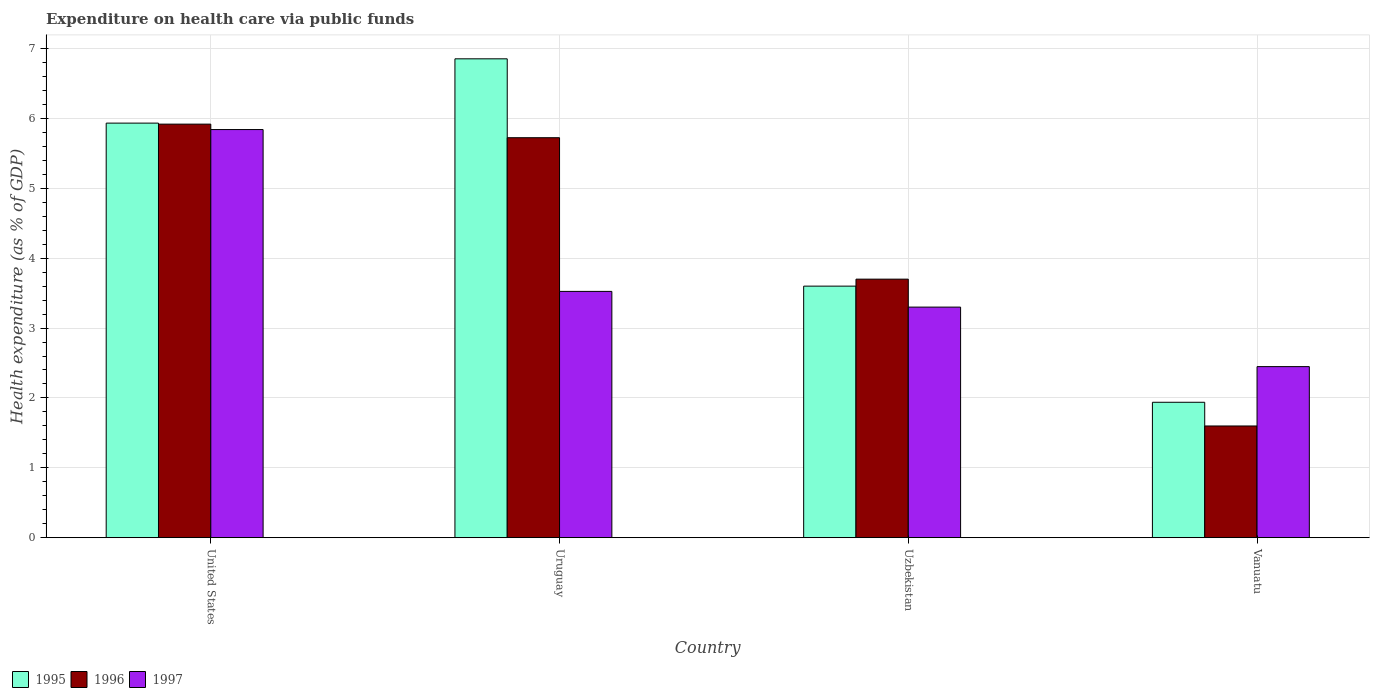How many bars are there on the 3rd tick from the left?
Ensure brevity in your answer.  3. What is the label of the 2nd group of bars from the left?
Keep it short and to the point. Uruguay. What is the expenditure made on health care in 1996 in United States?
Keep it short and to the point. 5.92. Across all countries, what is the maximum expenditure made on health care in 1997?
Ensure brevity in your answer.  5.84. Across all countries, what is the minimum expenditure made on health care in 1996?
Make the answer very short. 1.6. In which country was the expenditure made on health care in 1995 maximum?
Ensure brevity in your answer.  Uruguay. In which country was the expenditure made on health care in 1996 minimum?
Your answer should be very brief. Vanuatu. What is the total expenditure made on health care in 1996 in the graph?
Offer a terse response. 16.94. What is the difference between the expenditure made on health care in 1995 in United States and that in Uruguay?
Offer a terse response. -0.92. What is the difference between the expenditure made on health care in 1996 in Uzbekistan and the expenditure made on health care in 1997 in United States?
Your response must be concise. -2.14. What is the average expenditure made on health care in 1995 per country?
Make the answer very short. 4.58. What is the difference between the expenditure made on health care of/in 1997 and expenditure made on health care of/in 1996 in Uzbekistan?
Keep it short and to the point. -0.4. What is the ratio of the expenditure made on health care in 1995 in United States to that in Vanuatu?
Keep it short and to the point. 3.06. Is the expenditure made on health care in 1996 in United States less than that in Uruguay?
Provide a succinct answer. No. Is the difference between the expenditure made on health care in 1997 in United States and Uzbekistan greater than the difference between the expenditure made on health care in 1996 in United States and Uzbekistan?
Provide a succinct answer. Yes. What is the difference between the highest and the second highest expenditure made on health care in 1997?
Your response must be concise. -0.22. What is the difference between the highest and the lowest expenditure made on health care in 1996?
Make the answer very short. 4.32. In how many countries, is the expenditure made on health care in 1997 greater than the average expenditure made on health care in 1997 taken over all countries?
Offer a very short reply. 1. What does the 3rd bar from the left in Vanuatu represents?
Provide a succinct answer. 1997. Is it the case that in every country, the sum of the expenditure made on health care in 1995 and expenditure made on health care in 1997 is greater than the expenditure made on health care in 1996?
Offer a terse response. Yes. Are all the bars in the graph horizontal?
Give a very brief answer. No. What is the difference between two consecutive major ticks on the Y-axis?
Provide a succinct answer. 1. Are the values on the major ticks of Y-axis written in scientific E-notation?
Give a very brief answer. No. How are the legend labels stacked?
Provide a short and direct response. Horizontal. What is the title of the graph?
Your answer should be compact. Expenditure on health care via public funds. Does "2004" appear as one of the legend labels in the graph?
Keep it short and to the point. No. What is the label or title of the Y-axis?
Offer a terse response. Health expenditure (as % of GDP). What is the Health expenditure (as % of GDP) of 1995 in United States?
Your answer should be very brief. 5.93. What is the Health expenditure (as % of GDP) in 1996 in United States?
Your answer should be very brief. 5.92. What is the Health expenditure (as % of GDP) of 1997 in United States?
Your response must be concise. 5.84. What is the Health expenditure (as % of GDP) of 1995 in Uruguay?
Offer a very short reply. 6.85. What is the Health expenditure (as % of GDP) in 1996 in Uruguay?
Offer a terse response. 5.72. What is the Health expenditure (as % of GDP) in 1997 in Uruguay?
Offer a very short reply. 3.52. What is the Health expenditure (as % of GDP) in 1995 in Uzbekistan?
Provide a succinct answer. 3.6. What is the Health expenditure (as % of GDP) in 1996 in Uzbekistan?
Provide a succinct answer. 3.7. What is the Health expenditure (as % of GDP) in 1997 in Uzbekistan?
Keep it short and to the point. 3.3. What is the Health expenditure (as % of GDP) of 1995 in Vanuatu?
Make the answer very short. 1.94. What is the Health expenditure (as % of GDP) in 1996 in Vanuatu?
Your response must be concise. 1.6. What is the Health expenditure (as % of GDP) in 1997 in Vanuatu?
Your answer should be compact. 2.45. Across all countries, what is the maximum Health expenditure (as % of GDP) in 1995?
Your answer should be compact. 6.85. Across all countries, what is the maximum Health expenditure (as % of GDP) in 1996?
Keep it short and to the point. 5.92. Across all countries, what is the maximum Health expenditure (as % of GDP) of 1997?
Your response must be concise. 5.84. Across all countries, what is the minimum Health expenditure (as % of GDP) in 1995?
Make the answer very short. 1.94. Across all countries, what is the minimum Health expenditure (as % of GDP) in 1996?
Provide a succinct answer. 1.6. Across all countries, what is the minimum Health expenditure (as % of GDP) in 1997?
Your answer should be compact. 2.45. What is the total Health expenditure (as % of GDP) in 1995 in the graph?
Offer a terse response. 18.32. What is the total Health expenditure (as % of GDP) in 1996 in the graph?
Your answer should be very brief. 16.94. What is the total Health expenditure (as % of GDP) of 1997 in the graph?
Your response must be concise. 15.11. What is the difference between the Health expenditure (as % of GDP) of 1995 in United States and that in Uruguay?
Offer a terse response. -0.92. What is the difference between the Health expenditure (as % of GDP) in 1996 in United States and that in Uruguay?
Your answer should be very brief. 0.19. What is the difference between the Health expenditure (as % of GDP) of 1997 in United States and that in Uruguay?
Offer a very short reply. 2.32. What is the difference between the Health expenditure (as % of GDP) in 1995 in United States and that in Uzbekistan?
Provide a short and direct response. 2.33. What is the difference between the Health expenditure (as % of GDP) of 1996 in United States and that in Uzbekistan?
Offer a very short reply. 2.22. What is the difference between the Health expenditure (as % of GDP) in 1997 in United States and that in Uzbekistan?
Provide a short and direct response. 2.54. What is the difference between the Health expenditure (as % of GDP) in 1995 in United States and that in Vanuatu?
Ensure brevity in your answer.  3.99. What is the difference between the Health expenditure (as % of GDP) in 1996 in United States and that in Vanuatu?
Ensure brevity in your answer.  4.32. What is the difference between the Health expenditure (as % of GDP) of 1997 in United States and that in Vanuatu?
Make the answer very short. 3.39. What is the difference between the Health expenditure (as % of GDP) in 1995 in Uruguay and that in Uzbekistan?
Your response must be concise. 3.25. What is the difference between the Health expenditure (as % of GDP) of 1996 in Uruguay and that in Uzbekistan?
Your answer should be very brief. 2.02. What is the difference between the Health expenditure (as % of GDP) of 1997 in Uruguay and that in Uzbekistan?
Ensure brevity in your answer.  0.22. What is the difference between the Health expenditure (as % of GDP) in 1995 in Uruguay and that in Vanuatu?
Your response must be concise. 4.91. What is the difference between the Health expenditure (as % of GDP) of 1996 in Uruguay and that in Vanuatu?
Your answer should be very brief. 4.12. What is the difference between the Health expenditure (as % of GDP) of 1997 in Uruguay and that in Vanuatu?
Provide a succinct answer. 1.08. What is the difference between the Health expenditure (as % of GDP) of 1995 in Uzbekistan and that in Vanuatu?
Provide a short and direct response. 1.66. What is the difference between the Health expenditure (as % of GDP) in 1996 in Uzbekistan and that in Vanuatu?
Your answer should be compact. 2.1. What is the difference between the Health expenditure (as % of GDP) of 1997 in Uzbekistan and that in Vanuatu?
Give a very brief answer. 0.85. What is the difference between the Health expenditure (as % of GDP) in 1995 in United States and the Health expenditure (as % of GDP) in 1996 in Uruguay?
Ensure brevity in your answer.  0.21. What is the difference between the Health expenditure (as % of GDP) in 1995 in United States and the Health expenditure (as % of GDP) in 1997 in Uruguay?
Provide a short and direct response. 2.41. What is the difference between the Health expenditure (as % of GDP) in 1996 in United States and the Health expenditure (as % of GDP) in 1997 in Uruguay?
Give a very brief answer. 2.39. What is the difference between the Health expenditure (as % of GDP) of 1995 in United States and the Health expenditure (as % of GDP) of 1996 in Uzbekistan?
Ensure brevity in your answer.  2.23. What is the difference between the Health expenditure (as % of GDP) in 1995 in United States and the Health expenditure (as % of GDP) in 1997 in Uzbekistan?
Your response must be concise. 2.63. What is the difference between the Health expenditure (as % of GDP) in 1996 in United States and the Health expenditure (as % of GDP) in 1997 in Uzbekistan?
Provide a short and direct response. 2.62. What is the difference between the Health expenditure (as % of GDP) of 1995 in United States and the Health expenditure (as % of GDP) of 1996 in Vanuatu?
Offer a very short reply. 4.33. What is the difference between the Health expenditure (as % of GDP) in 1995 in United States and the Health expenditure (as % of GDP) in 1997 in Vanuatu?
Keep it short and to the point. 3.48. What is the difference between the Health expenditure (as % of GDP) in 1996 in United States and the Health expenditure (as % of GDP) in 1997 in Vanuatu?
Offer a very short reply. 3.47. What is the difference between the Health expenditure (as % of GDP) in 1995 in Uruguay and the Health expenditure (as % of GDP) in 1996 in Uzbekistan?
Your answer should be very brief. 3.15. What is the difference between the Health expenditure (as % of GDP) in 1995 in Uruguay and the Health expenditure (as % of GDP) in 1997 in Uzbekistan?
Your answer should be very brief. 3.55. What is the difference between the Health expenditure (as % of GDP) of 1996 in Uruguay and the Health expenditure (as % of GDP) of 1997 in Uzbekistan?
Make the answer very short. 2.42. What is the difference between the Health expenditure (as % of GDP) of 1995 in Uruguay and the Health expenditure (as % of GDP) of 1996 in Vanuatu?
Your answer should be very brief. 5.25. What is the difference between the Health expenditure (as % of GDP) of 1995 in Uruguay and the Health expenditure (as % of GDP) of 1997 in Vanuatu?
Give a very brief answer. 4.4. What is the difference between the Health expenditure (as % of GDP) of 1996 in Uruguay and the Health expenditure (as % of GDP) of 1997 in Vanuatu?
Provide a short and direct response. 3.28. What is the difference between the Health expenditure (as % of GDP) of 1995 in Uzbekistan and the Health expenditure (as % of GDP) of 1996 in Vanuatu?
Ensure brevity in your answer.  2. What is the difference between the Health expenditure (as % of GDP) of 1995 in Uzbekistan and the Health expenditure (as % of GDP) of 1997 in Vanuatu?
Offer a very short reply. 1.15. What is the difference between the Health expenditure (as % of GDP) in 1996 in Uzbekistan and the Health expenditure (as % of GDP) in 1997 in Vanuatu?
Make the answer very short. 1.25. What is the average Health expenditure (as % of GDP) in 1995 per country?
Offer a terse response. 4.58. What is the average Health expenditure (as % of GDP) of 1996 per country?
Keep it short and to the point. 4.24. What is the average Health expenditure (as % of GDP) of 1997 per country?
Your answer should be compact. 3.78. What is the difference between the Health expenditure (as % of GDP) in 1995 and Health expenditure (as % of GDP) in 1996 in United States?
Offer a terse response. 0.01. What is the difference between the Health expenditure (as % of GDP) in 1995 and Health expenditure (as % of GDP) in 1997 in United States?
Give a very brief answer. 0.09. What is the difference between the Health expenditure (as % of GDP) of 1996 and Health expenditure (as % of GDP) of 1997 in United States?
Offer a terse response. 0.08. What is the difference between the Health expenditure (as % of GDP) of 1995 and Health expenditure (as % of GDP) of 1996 in Uruguay?
Offer a very short reply. 1.13. What is the difference between the Health expenditure (as % of GDP) in 1995 and Health expenditure (as % of GDP) in 1997 in Uruguay?
Ensure brevity in your answer.  3.33. What is the difference between the Health expenditure (as % of GDP) in 1996 and Health expenditure (as % of GDP) in 1997 in Uruguay?
Give a very brief answer. 2.2. What is the difference between the Health expenditure (as % of GDP) of 1995 and Health expenditure (as % of GDP) of 1996 in Uzbekistan?
Offer a very short reply. -0.1. What is the difference between the Health expenditure (as % of GDP) of 1995 and Health expenditure (as % of GDP) of 1997 in Uzbekistan?
Offer a terse response. 0.3. What is the difference between the Health expenditure (as % of GDP) of 1995 and Health expenditure (as % of GDP) of 1996 in Vanuatu?
Offer a very short reply. 0.34. What is the difference between the Health expenditure (as % of GDP) in 1995 and Health expenditure (as % of GDP) in 1997 in Vanuatu?
Keep it short and to the point. -0.51. What is the difference between the Health expenditure (as % of GDP) of 1996 and Health expenditure (as % of GDP) of 1997 in Vanuatu?
Offer a very short reply. -0.85. What is the ratio of the Health expenditure (as % of GDP) of 1995 in United States to that in Uruguay?
Give a very brief answer. 0.87. What is the ratio of the Health expenditure (as % of GDP) in 1996 in United States to that in Uruguay?
Offer a very short reply. 1.03. What is the ratio of the Health expenditure (as % of GDP) in 1997 in United States to that in Uruguay?
Make the answer very short. 1.66. What is the ratio of the Health expenditure (as % of GDP) of 1995 in United States to that in Uzbekistan?
Provide a short and direct response. 1.65. What is the ratio of the Health expenditure (as % of GDP) of 1996 in United States to that in Uzbekistan?
Your answer should be very brief. 1.6. What is the ratio of the Health expenditure (as % of GDP) in 1997 in United States to that in Uzbekistan?
Your answer should be compact. 1.77. What is the ratio of the Health expenditure (as % of GDP) in 1995 in United States to that in Vanuatu?
Your response must be concise. 3.06. What is the ratio of the Health expenditure (as % of GDP) in 1996 in United States to that in Vanuatu?
Give a very brief answer. 3.7. What is the ratio of the Health expenditure (as % of GDP) of 1997 in United States to that in Vanuatu?
Your answer should be very brief. 2.39. What is the ratio of the Health expenditure (as % of GDP) of 1995 in Uruguay to that in Uzbekistan?
Offer a very short reply. 1.9. What is the ratio of the Health expenditure (as % of GDP) of 1996 in Uruguay to that in Uzbekistan?
Make the answer very short. 1.55. What is the ratio of the Health expenditure (as % of GDP) in 1997 in Uruguay to that in Uzbekistan?
Your response must be concise. 1.07. What is the ratio of the Health expenditure (as % of GDP) in 1995 in Uruguay to that in Vanuatu?
Provide a succinct answer. 3.54. What is the ratio of the Health expenditure (as % of GDP) of 1996 in Uruguay to that in Vanuatu?
Your response must be concise. 3.58. What is the ratio of the Health expenditure (as % of GDP) in 1997 in Uruguay to that in Vanuatu?
Your answer should be compact. 1.44. What is the ratio of the Health expenditure (as % of GDP) of 1995 in Uzbekistan to that in Vanuatu?
Keep it short and to the point. 1.86. What is the ratio of the Health expenditure (as % of GDP) in 1996 in Uzbekistan to that in Vanuatu?
Provide a succinct answer. 2.31. What is the ratio of the Health expenditure (as % of GDP) in 1997 in Uzbekistan to that in Vanuatu?
Offer a terse response. 1.35. What is the difference between the highest and the second highest Health expenditure (as % of GDP) of 1995?
Provide a succinct answer. 0.92. What is the difference between the highest and the second highest Health expenditure (as % of GDP) of 1996?
Keep it short and to the point. 0.19. What is the difference between the highest and the second highest Health expenditure (as % of GDP) of 1997?
Offer a very short reply. 2.32. What is the difference between the highest and the lowest Health expenditure (as % of GDP) of 1995?
Your answer should be compact. 4.91. What is the difference between the highest and the lowest Health expenditure (as % of GDP) of 1996?
Provide a succinct answer. 4.32. What is the difference between the highest and the lowest Health expenditure (as % of GDP) in 1997?
Your response must be concise. 3.39. 